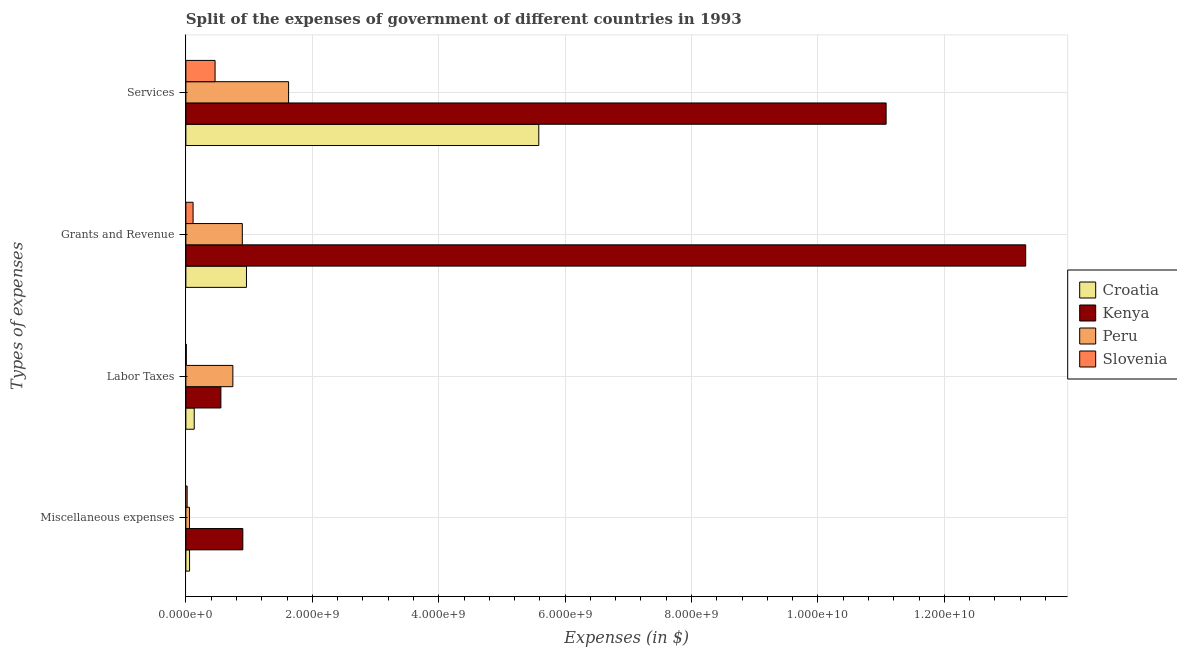How many groups of bars are there?
Your response must be concise. 4. How many bars are there on the 4th tick from the top?
Your answer should be compact. 4. How many bars are there on the 2nd tick from the bottom?
Your answer should be very brief. 4. What is the label of the 3rd group of bars from the top?
Provide a short and direct response. Labor Taxes. What is the amount spent on services in Slovenia?
Offer a very short reply. 4.62e+08. Across all countries, what is the maximum amount spent on miscellaneous expenses?
Offer a very short reply. 9.01e+08. Across all countries, what is the minimum amount spent on miscellaneous expenses?
Ensure brevity in your answer.  2.00e+07. In which country was the amount spent on miscellaneous expenses maximum?
Offer a terse response. Kenya. In which country was the amount spent on services minimum?
Keep it short and to the point. Slovenia. What is the total amount spent on labor taxes in the graph?
Keep it short and to the point. 1.44e+09. What is the difference between the amount spent on grants and revenue in Kenya and that in Slovenia?
Provide a succinct answer. 1.32e+1. What is the difference between the amount spent on services in Peru and the amount spent on grants and revenue in Slovenia?
Your response must be concise. 1.51e+09. What is the average amount spent on services per country?
Your answer should be very brief. 4.69e+09. What is the difference between the amount spent on labor taxes and amount spent on services in Croatia?
Offer a terse response. -5.45e+09. What is the ratio of the amount spent on grants and revenue in Croatia to that in Peru?
Give a very brief answer. 1.07. What is the difference between the highest and the second highest amount spent on labor taxes?
Provide a short and direct response. 1.89e+08. What is the difference between the highest and the lowest amount spent on labor taxes?
Offer a terse response. 7.37e+08. Is it the case that in every country, the sum of the amount spent on miscellaneous expenses and amount spent on services is greater than the sum of amount spent on labor taxes and amount spent on grants and revenue?
Your response must be concise. No. What does the 1st bar from the top in Miscellaneous expenses represents?
Offer a terse response. Slovenia. What does the 3rd bar from the bottom in Grants and Revenue represents?
Give a very brief answer. Peru. Is it the case that in every country, the sum of the amount spent on miscellaneous expenses and amount spent on labor taxes is greater than the amount spent on grants and revenue?
Offer a very short reply. No. How many bars are there?
Keep it short and to the point. 16. Are all the bars in the graph horizontal?
Keep it short and to the point. Yes. What is the difference between two consecutive major ticks on the X-axis?
Provide a succinct answer. 2.00e+09. Does the graph contain any zero values?
Keep it short and to the point. No. Where does the legend appear in the graph?
Your response must be concise. Center right. How many legend labels are there?
Ensure brevity in your answer.  4. How are the legend labels stacked?
Offer a terse response. Vertical. What is the title of the graph?
Your answer should be very brief. Split of the expenses of government of different countries in 1993. Does "Philippines" appear as one of the legend labels in the graph?
Offer a terse response. No. What is the label or title of the X-axis?
Make the answer very short. Expenses (in $). What is the label or title of the Y-axis?
Keep it short and to the point. Types of expenses. What is the Expenses (in $) in Croatia in Miscellaneous expenses?
Your response must be concise. 5.83e+07. What is the Expenses (in $) of Kenya in Miscellaneous expenses?
Give a very brief answer. 9.01e+08. What is the Expenses (in $) in Peru in Miscellaneous expenses?
Ensure brevity in your answer.  5.70e+07. What is the Expenses (in $) of Slovenia in Miscellaneous expenses?
Your answer should be very brief. 2.00e+07. What is the Expenses (in $) of Croatia in Labor Taxes?
Provide a succinct answer. 1.32e+08. What is the Expenses (in $) in Kenya in Labor Taxes?
Offer a terse response. 5.54e+08. What is the Expenses (in $) in Peru in Labor Taxes?
Offer a terse response. 7.43e+08. What is the Expenses (in $) of Slovenia in Labor Taxes?
Your answer should be very brief. 6.68e+06. What is the Expenses (in $) of Croatia in Grants and Revenue?
Keep it short and to the point. 9.59e+08. What is the Expenses (in $) in Kenya in Grants and Revenue?
Provide a succinct answer. 1.33e+1. What is the Expenses (in $) in Peru in Grants and Revenue?
Provide a succinct answer. 8.93e+08. What is the Expenses (in $) of Slovenia in Grants and Revenue?
Ensure brevity in your answer.  1.14e+08. What is the Expenses (in $) of Croatia in Services?
Your response must be concise. 5.58e+09. What is the Expenses (in $) in Kenya in Services?
Keep it short and to the point. 1.11e+1. What is the Expenses (in $) in Peru in Services?
Your answer should be very brief. 1.62e+09. What is the Expenses (in $) in Slovenia in Services?
Give a very brief answer. 4.62e+08. Across all Types of expenses, what is the maximum Expenses (in $) in Croatia?
Make the answer very short. 5.58e+09. Across all Types of expenses, what is the maximum Expenses (in $) in Kenya?
Keep it short and to the point. 1.33e+1. Across all Types of expenses, what is the maximum Expenses (in $) of Peru?
Your response must be concise. 1.62e+09. Across all Types of expenses, what is the maximum Expenses (in $) of Slovenia?
Provide a short and direct response. 4.62e+08. Across all Types of expenses, what is the minimum Expenses (in $) in Croatia?
Offer a very short reply. 5.83e+07. Across all Types of expenses, what is the minimum Expenses (in $) in Kenya?
Offer a very short reply. 5.54e+08. Across all Types of expenses, what is the minimum Expenses (in $) of Peru?
Make the answer very short. 5.70e+07. Across all Types of expenses, what is the minimum Expenses (in $) of Slovenia?
Make the answer very short. 6.68e+06. What is the total Expenses (in $) in Croatia in the graph?
Offer a very short reply. 6.73e+09. What is the total Expenses (in $) in Kenya in the graph?
Your answer should be compact. 2.58e+1. What is the total Expenses (in $) of Peru in the graph?
Offer a very short reply. 3.32e+09. What is the total Expenses (in $) in Slovenia in the graph?
Make the answer very short. 6.03e+08. What is the difference between the Expenses (in $) of Croatia in Miscellaneous expenses and that in Labor Taxes?
Offer a terse response. -7.38e+07. What is the difference between the Expenses (in $) in Kenya in Miscellaneous expenses and that in Labor Taxes?
Offer a very short reply. 3.47e+08. What is the difference between the Expenses (in $) in Peru in Miscellaneous expenses and that in Labor Taxes?
Offer a terse response. -6.86e+08. What is the difference between the Expenses (in $) of Slovenia in Miscellaneous expenses and that in Labor Taxes?
Keep it short and to the point. 1.34e+07. What is the difference between the Expenses (in $) of Croatia in Miscellaneous expenses and that in Grants and Revenue?
Your answer should be very brief. -9.00e+08. What is the difference between the Expenses (in $) in Kenya in Miscellaneous expenses and that in Grants and Revenue?
Give a very brief answer. -1.24e+1. What is the difference between the Expenses (in $) of Peru in Miscellaneous expenses and that in Grants and Revenue?
Ensure brevity in your answer.  -8.36e+08. What is the difference between the Expenses (in $) of Slovenia in Miscellaneous expenses and that in Grants and Revenue?
Your answer should be very brief. -9.39e+07. What is the difference between the Expenses (in $) of Croatia in Miscellaneous expenses and that in Services?
Provide a succinct answer. -5.52e+09. What is the difference between the Expenses (in $) in Kenya in Miscellaneous expenses and that in Services?
Give a very brief answer. -1.02e+1. What is the difference between the Expenses (in $) in Peru in Miscellaneous expenses and that in Services?
Provide a succinct answer. -1.57e+09. What is the difference between the Expenses (in $) in Slovenia in Miscellaneous expenses and that in Services?
Provide a succinct answer. -4.42e+08. What is the difference between the Expenses (in $) in Croatia in Labor Taxes and that in Grants and Revenue?
Your answer should be compact. -8.27e+08. What is the difference between the Expenses (in $) in Kenya in Labor Taxes and that in Grants and Revenue?
Your response must be concise. -1.27e+1. What is the difference between the Expenses (in $) of Peru in Labor Taxes and that in Grants and Revenue?
Offer a terse response. -1.49e+08. What is the difference between the Expenses (in $) of Slovenia in Labor Taxes and that in Grants and Revenue?
Offer a terse response. -1.07e+08. What is the difference between the Expenses (in $) in Croatia in Labor Taxes and that in Services?
Your answer should be very brief. -5.45e+09. What is the difference between the Expenses (in $) in Kenya in Labor Taxes and that in Services?
Your answer should be very brief. -1.05e+1. What is the difference between the Expenses (in $) of Peru in Labor Taxes and that in Services?
Your answer should be compact. -8.82e+08. What is the difference between the Expenses (in $) of Slovenia in Labor Taxes and that in Services?
Provide a succinct answer. -4.55e+08. What is the difference between the Expenses (in $) of Croatia in Grants and Revenue and that in Services?
Make the answer very short. -4.62e+09. What is the difference between the Expenses (in $) in Kenya in Grants and Revenue and that in Services?
Offer a terse response. 2.21e+09. What is the difference between the Expenses (in $) of Peru in Grants and Revenue and that in Services?
Your answer should be compact. -7.32e+08. What is the difference between the Expenses (in $) in Slovenia in Grants and Revenue and that in Services?
Ensure brevity in your answer.  -3.48e+08. What is the difference between the Expenses (in $) in Croatia in Miscellaneous expenses and the Expenses (in $) in Kenya in Labor Taxes?
Offer a very short reply. -4.96e+08. What is the difference between the Expenses (in $) in Croatia in Miscellaneous expenses and the Expenses (in $) in Peru in Labor Taxes?
Ensure brevity in your answer.  -6.85e+08. What is the difference between the Expenses (in $) in Croatia in Miscellaneous expenses and the Expenses (in $) in Slovenia in Labor Taxes?
Make the answer very short. 5.16e+07. What is the difference between the Expenses (in $) in Kenya in Miscellaneous expenses and the Expenses (in $) in Peru in Labor Taxes?
Your response must be concise. 1.58e+08. What is the difference between the Expenses (in $) in Kenya in Miscellaneous expenses and the Expenses (in $) in Slovenia in Labor Taxes?
Offer a terse response. 8.94e+08. What is the difference between the Expenses (in $) in Peru in Miscellaneous expenses and the Expenses (in $) in Slovenia in Labor Taxes?
Offer a terse response. 5.03e+07. What is the difference between the Expenses (in $) of Croatia in Miscellaneous expenses and the Expenses (in $) of Kenya in Grants and Revenue?
Offer a terse response. -1.32e+1. What is the difference between the Expenses (in $) of Croatia in Miscellaneous expenses and the Expenses (in $) of Peru in Grants and Revenue?
Offer a very short reply. -8.34e+08. What is the difference between the Expenses (in $) in Croatia in Miscellaneous expenses and the Expenses (in $) in Slovenia in Grants and Revenue?
Ensure brevity in your answer.  -5.56e+07. What is the difference between the Expenses (in $) in Kenya in Miscellaneous expenses and the Expenses (in $) in Peru in Grants and Revenue?
Provide a short and direct response. 8.22e+06. What is the difference between the Expenses (in $) of Kenya in Miscellaneous expenses and the Expenses (in $) of Slovenia in Grants and Revenue?
Provide a short and direct response. 7.87e+08. What is the difference between the Expenses (in $) of Peru in Miscellaneous expenses and the Expenses (in $) of Slovenia in Grants and Revenue?
Offer a very short reply. -5.69e+07. What is the difference between the Expenses (in $) in Croatia in Miscellaneous expenses and the Expenses (in $) in Kenya in Services?
Ensure brevity in your answer.  -1.10e+1. What is the difference between the Expenses (in $) of Croatia in Miscellaneous expenses and the Expenses (in $) of Peru in Services?
Your response must be concise. -1.57e+09. What is the difference between the Expenses (in $) in Croatia in Miscellaneous expenses and the Expenses (in $) in Slovenia in Services?
Keep it short and to the point. -4.04e+08. What is the difference between the Expenses (in $) of Kenya in Miscellaneous expenses and the Expenses (in $) of Peru in Services?
Offer a terse response. -7.24e+08. What is the difference between the Expenses (in $) in Kenya in Miscellaneous expenses and the Expenses (in $) in Slovenia in Services?
Provide a succinct answer. 4.39e+08. What is the difference between the Expenses (in $) in Peru in Miscellaneous expenses and the Expenses (in $) in Slovenia in Services?
Keep it short and to the point. -4.05e+08. What is the difference between the Expenses (in $) of Croatia in Labor Taxes and the Expenses (in $) of Kenya in Grants and Revenue?
Provide a short and direct response. -1.32e+1. What is the difference between the Expenses (in $) in Croatia in Labor Taxes and the Expenses (in $) in Peru in Grants and Revenue?
Your answer should be compact. -7.61e+08. What is the difference between the Expenses (in $) in Croatia in Labor Taxes and the Expenses (in $) in Slovenia in Grants and Revenue?
Keep it short and to the point. 1.82e+07. What is the difference between the Expenses (in $) of Kenya in Labor Taxes and the Expenses (in $) of Peru in Grants and Revenue?
Make the answer very short. -3.39e+08. What is the difference between the Expenses (in $) in Kenya in Labor Taxes and the Expenses (in $) in Slovenia in Grants and Revenue?
Ensure brevity in your answer.  4.40e+08. What is the difference between the Expenses (in $) in Peru in Labor Taxes and the Expenses (in $) in Slovenia in Grants and Revenue?
Your answer should be very brief. 6.29e+08. What is the difference between the Expenses (in $) in Croatia in Labor Taxes and the Expenses (in $) in Kenya in Services?
Your answer should be compact. -1.09e+1. What is the difference between the Expenses (in $) in Croatia in Labor Taxes and the Expenses (in $) in Peru in Services?
Your answer should be very brief. -1.49e+09. What is the difference between the Expenses (in $) of Croatia in Labor Taxes and the Expenses (in $) of Slovenia in Services?
Offer a terse response. -3.30e+08. What is the difference between the Expenses (in $) in Kenya in Labor Taxes and the Expenses (in $) in Peru in Services?
Offer a terse response. -1.07e+09. What is the difference between the Expenses (in $) of Kenya in Labor Taxes and the Expenses (in $) of Slovenia in Services?
Your answer should be very brief. 9.21e+07. What is the difference between the Expenses (in $) in Peru in Labor Taxes and the Expenses (in $) in Slovenia in Services?
Your answer should be very brief. 2.81e+08. What is the difference between the Expenses (in $) in Croatia in Grants and Revenue and the Expenses (in $) in Kenya in Services?
Make the answer very short. -1.01e+1. What is the difference between the Expenses (in $) in Croatia in Grants and Revenue and the Expenses (in $) in Peru in Services?
Your answer should be very brief. -6.66e+08. What is the difference between the Expenses (in $) of Croatia in Grants and Revenue and the Expenses (in $) of Slovenia in Services?
Keep it short and to the point. 4.97e+08. What is the difference between the Expenses (in $) in Kenya in Grants and Revenue and the Expenses (in $) in Peru in Services?
Keep it short and to the point. 1.17e+1. What is the difference between the Expenses (in $) in Kenya in Grants and Revenue and the Expenses (in $) in Slovenia in Services?
Ensure brevity in your answer.  1.28e+1. What is the difference between the Expenses (in $) of Peru in Grants and Revenue and the Expenses (in $) of Slovenia in Services?
Your answer should be compact. 4.31e+08. What is the average Expenses (in $) of Croatia per Types of expenses?
Offer a very short reply. 1.68e+09. What is the average Expenses (in $) of Kenya per Types of expenses?
Your answer should be compact. 6.45e+09. What is the average Expenses (in $) of Peru per Types of expenses?
Your response must be concise. 8.30e+08. What is the average Expenses (in $) of Slovenia per Types of expenses?
Provide a short and direct response. 1.51e+08. What is the difference between the Expenses (in $) of Croatia and Expenses (in $) of Kenya in Miscellaneous expenses?
Give a very brief answer. -8.43e+08. What is the difference between the Expenses (in $) in Croatia and Expenses (in $) in Peru in Miscellaneous expenses?
Give a very brief answer. 1.30e+06. What is the difference between the Expenses (in $) in Croatia and Expenses (in $) in Slovenia in Miscellaneous expenses?
Make the answer very short. 3.83e+07. What is the difference between the Expenses (in $) of Kenya and Expenses (in $) of Peru in Miscellaneous expenses?
Your response must be concise. 8.44e+08. What is the difference between the Expenses (in $) in Kenya and Expenses (in $) in Slovenia in Miscellaneous expenses?
Ensure brevity in your answer.  8.81e+08. What is the difference between the Expenses (in $) of Peru and Expenses (in $) of Slovenia in Miscellaneous expenses?
Your answer should be compact. 3.70e+07. What is the difference between the Expenses (in $) of Croatia and Expenses (in $) of Kenya in Labor Taxes?
Your response must be concise. -4.22e+08. What is the difference between the Expenses (in $) of Croatia and Expenses (in $) of Peru in Labor Taxes?
Give a very brief answer. -6.11e+08. What is the difference between the Expenses (in $) in Croatia and Expenses (in $) in Slovenia in Labor Taxes?
Keep it short and to the point. 1.25e+08. What is the difference between the Expenses (in $) in Kenya and Expenses (in $) in Peru in Labor Taxes?
Your response must be concise. -1.89e+08. What is the difference between the Expenses (in $) of Kenya and Expenses (in $) of Slovenia in Labor Taxes?
Ensure brevity in your answer.  5.47e+08. What is the difference between the Expenses (in $) in Peru and Expenses (in $) in Slovenia in Labor Taxes?
Offer a terse response. 7.37e+08. What is the difference between the Expenses (in $) in Croatia and Expenses (in $) in Kenya in Grants and Revenue?
Your response must be concise. -1.23e+1. What is the difference between the Expenses (in $) of Croatia and Expenses (in $) of Peru in Grants and Revenue?
Your response must be concise. 6.58e+07. What is the difference between the Expenses (in $) of Croatia and Expenses (in $) of Slovenia in Grants and Revenue?
Make the answer very short. 8.45e+08. What is the difference between the Expenses (in $) in Kenya and Expenses (in $) in Peru in Grants and Revenue?
Ensure brevity in your answer.  1.24e+1. What is the difference between the Expenses (in $) of Kenya and Expenses (in $) of Slovenia in Grants and Revenue?
Ensure brevity in your answer.  1.32e+1. What is the difference between the Expenses (in $) in Peru and Expenses (in $) in Slovenia in Grants and Revenue?
Ensure brevity in your answer.  7.79e+08. What is the difference between the Expenses (in $) in Croatia and Expenses (in $) in Kenya in Services?
Offer a very short reply. -5.49e+09. What is the difference between the Expenses (in $) in Croatia and Expenses (in $) in Peru in Services?
Your response must be concise. 3.96e+09. What is the difference between the Expenses (in $) in Croatia and Expenses (in $) in Slovenia in Services?
Your answer should be compact. 5.12e+09. What is the difference between the Expenses (in $) in Kenya and Expenses (in $) in Peru in Services?
Ensure brevity in your answer.  9.45e+09. What is the difference between the Expenses (in $) in Kenya and Expenses (in $) in Slovenia in Services?
Make the answer very short. 1.06e+1. What is the difference between the Expenses (in $) of Peru and Expenses (in $) of Slovenia in Services?
Give a very brief answer. 1.16e+09. What is the ratio of the Expenses (in $) in Croatia in Miscellaneous expenses to that in Labor Taxes?
Offer a very short reply. 0.44. What is the ratio of the Expenses (in $) in Kenya in Miscellaneous expenses to that in Labor Taxes?
Provide a succinct answer. 1.63. What is the ratio of the Expenses (in $) in Peru in Miscellaneous expenses to that in Labor Taxes?
Offer a very short reply. 0.08. What is the ratio of the Expenses (in $) of Slovenia in Miscellaneous expenses to that in Labor Taxes?
Your answer should be compact. 3. What is the ratio of the Expenses (in $) of Croatia in Miscellaneous expenses to that in Grants and Revenue?
Ensure brevity in your answer.  0.06. What is the ratio of the Expenses (in $) in Kenya in Miscellaneous expenses to that in Grants and Revenue?
Offer a terse response. 0.07. What is the ratio of the Expenses (in $) of Peru in Miscellaneous expenses to that in Grants and Revenue?
Your response must be concise. 0.06. What is the ratio of the Expenses (in $) of Slovenia in Miscellaneous expenses to that in Grants and Revenue?
Make the answer very short. 0.18. What is the ratio of the Expenses (in $) in Croatia in Miscellaneous expenses to that in Services?
Provide a short and direct response. 0.01. What is the ratio of the Expenses (in $) of Kenya in Miscellaneous expenses to that in Services?
Your answer should be very brief. 0.08. What is the ratio of the Expenses (in $) in Peru in Miscellaneous expenses to that in Services?
Your response must be concise. 0.04. What is the ratio of the Expenses (in $) of Slovenia in Miscellaneous expenses to that in Services?
Ensure brevity in your answer.  0.04. What is the ratio of the Expenses (in $) in Croatia in Labor Taxes to that in Grants and Revenue?
Ensure brevity in your answer.  0.14. What is the ratio of the Expenses (in $) in Kenya in Labor Taxes to that in Grants and Revenue?
Provide a succinct answer. 0.04. What is the ratio of the Expenses (in $) in Peru in Labor Taxes to that in Grants and Revenue?
Your response must be concise. 0.83. What is the ratio of the Expenses (in $) of Slovenia in Labor Taxes to that in Grants and Revenue?
Offer a terse response. 0.06. What is the ratio of the Expenses (in $) of Croatia in Labor Taxes to that in Services?
Provide a short and direct response. 0.02. What is the ratio of the Expenses (in $) in Peru in Labor Taxes to that in Services?
Offer a terse response. 0.46. What is the ratio of the Expenses (in $) of Slovenia in Labor Taxes to that in Services?
Make the answer very short. 0.01. What is the ratio of the Expenses (in $) in Croatia in Grants and Revenue to that in Services?
Your answer should be compact. 0.17. What is the ratio of the Expenses (in $) of Kenya in Grants and Revenue to that in Services?
Ensure brevity in your answer.  1.2. What is the ratio of the Expenses (in $) in Peru in Grants and Revenue to that in Services?
Keep it short and to the point. 0.55. What is the ratio of the Expenses (in $) of Slovenia in Grants and Revenue to that in Services?
Offer a terse response. 0.25. What is the difference between the highest and the second highest Expenses (in $) of Croatia?
Offer a terse response. 4.62e+09. What is the difference between the highest and the second highest Expenses (in $) in Kenya?
Your answer should be compact. 2.21e+09. What is the difference between the highest and the second highest Expenses (in $) of Peru?
Provide a short and direct response. 7.32e+08. What is the difference between the highest and the second highest Expenses (in $) of Slovenia?
Provide a short and direct response. 3.48e+08. What is the difference between the highest and the lowest Expenses (in $) of Croatia?
Give a very brief answer. 5.52e+09. What is the difference between the highest and the lowest Expenses (in $) in Kenya?
Make the answer very short. 1.27e+1. What is the difference between the highest and the lowest Expenses (in $) in Peru?
Your answer should be very brief. 1.57e+09. What is the difference between the highest and the lowest Expenses (in $) of Slovenia?
Offer a terse response. 4.55e+08. 